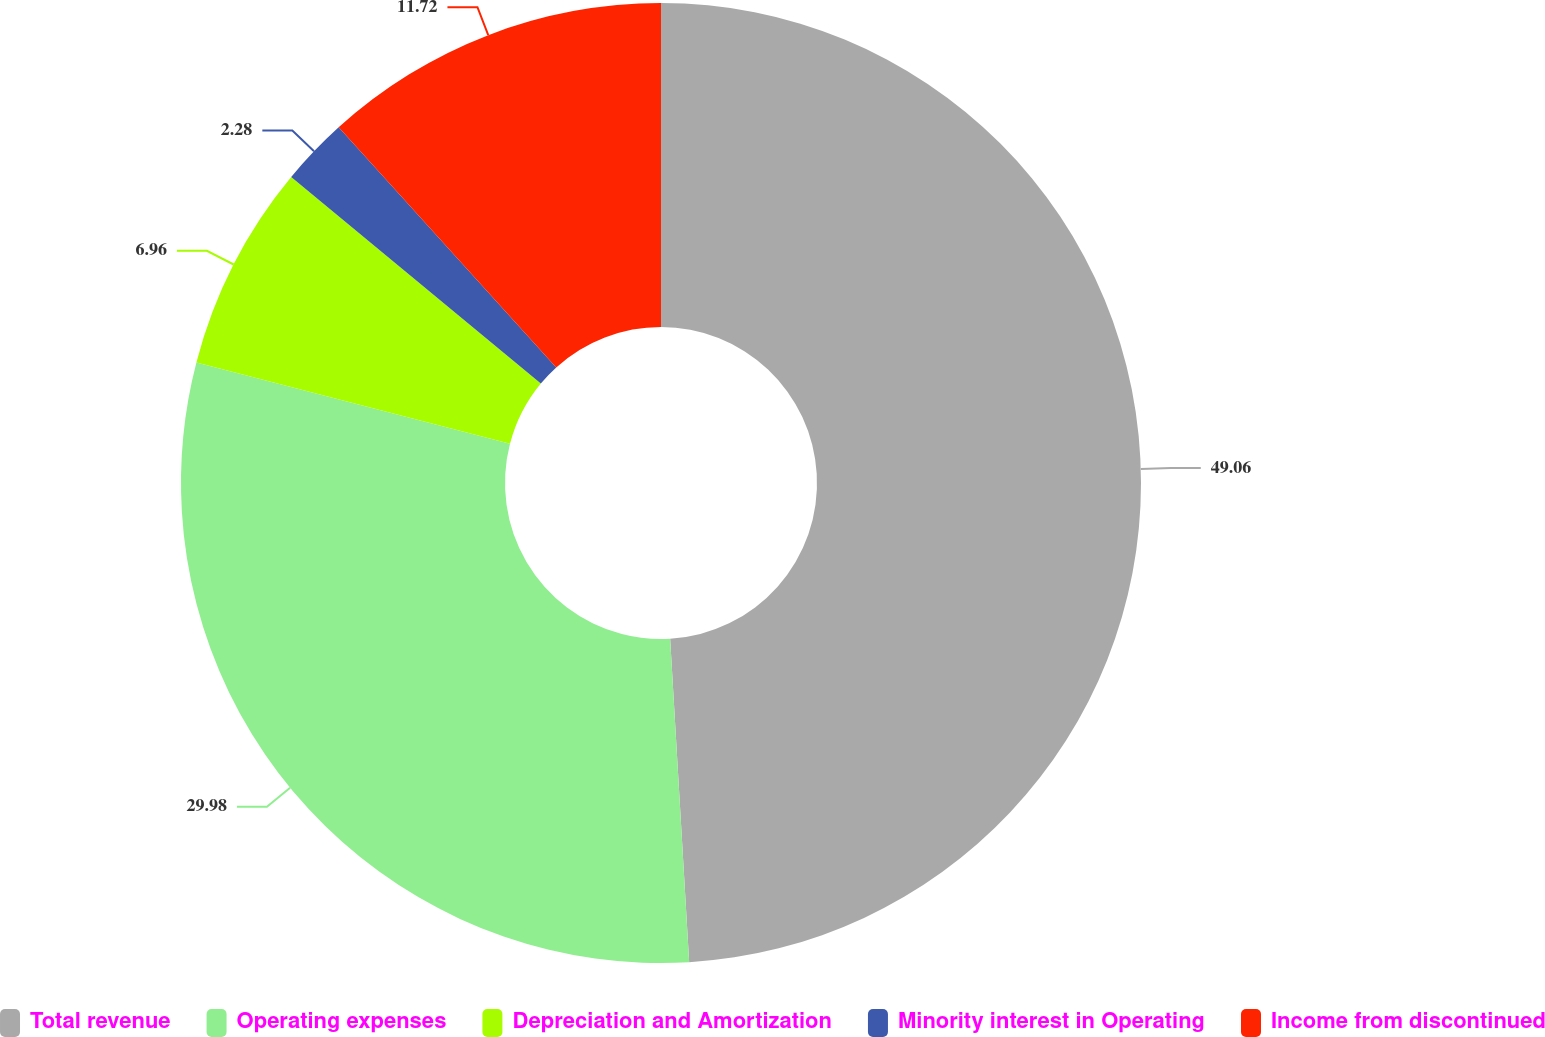Convert chart. <chart><loc_0><loc_0><loc_500><loc_500><pie_chart><fcel>Total revenue<fcel>Operating expenses<fcel>Depreciation and Amortization<fcel>Minority interest in Operating<fcel>Income from discontinued<nl><fcel>49.07%<fcel>29.98%<fcel>6.96%<fcel>2.28%<fcel>11.72%<nl></chart> 